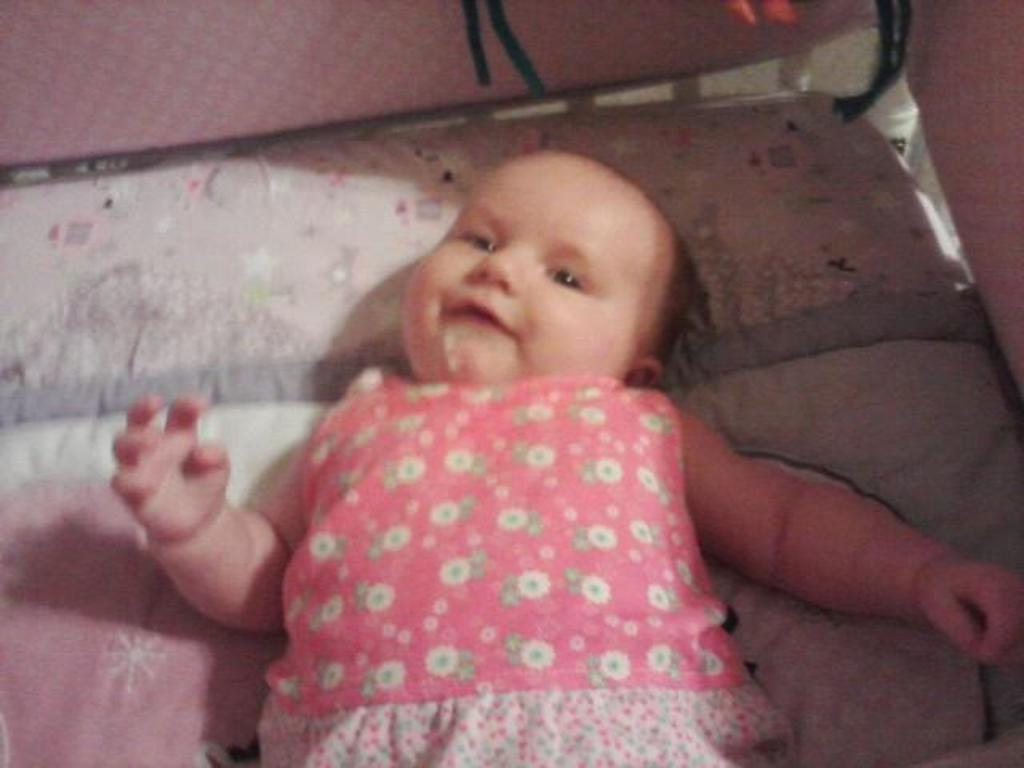What is the main subject of the image? There is a child in the image. Where is the child located in the image? The child is in the center of the image. What is the child wearing? The child is wearing a pink dress. What type of yoke is the child holding in the image? There is no yoke present in the image; the child is simply wearing a pink dress and is not holding any objects. 